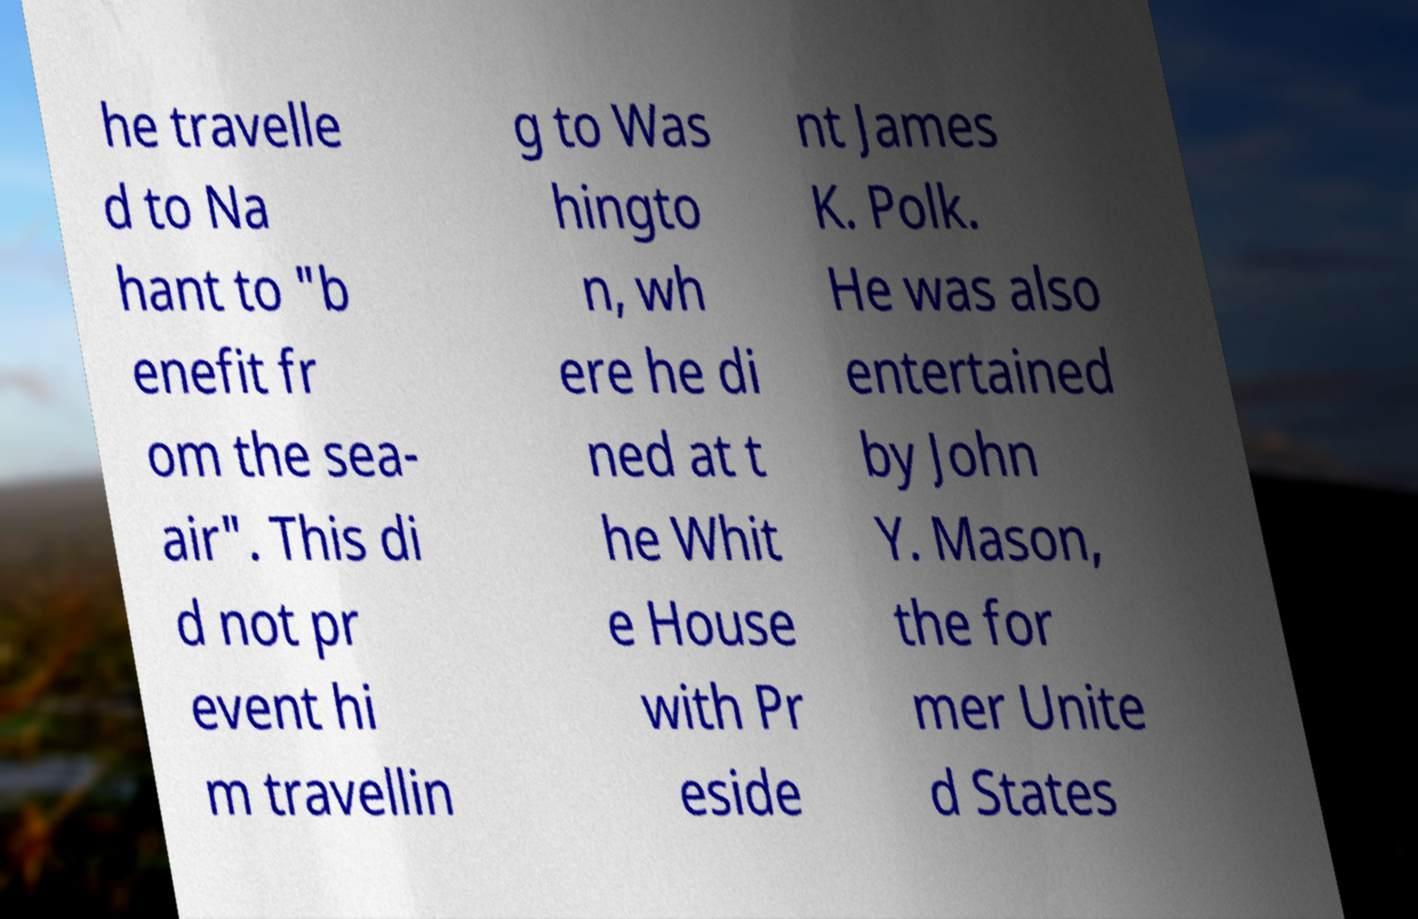There's text embedded in this image that I need extracted. Can you transcribe it verbatim? he travelle d to Na hant to "b enefit fr om the sea- air". This di d not pr event hi m travellin g to Was hingto n, wh ere he di ned at t he Whit e House with Pr eside nt James K. Polk. He was also entertained by John Y. Mason, the for mer Unite d States 